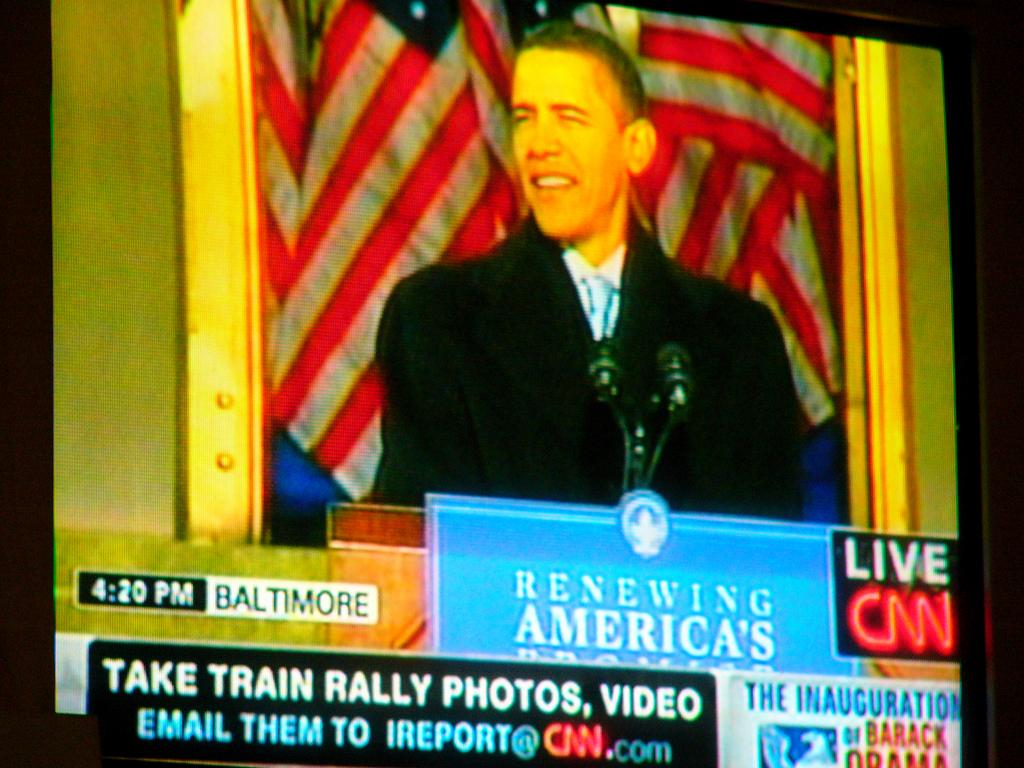<image>
Create a compact narrative representing the image presented. Obama talking at the podium Live on CNN 